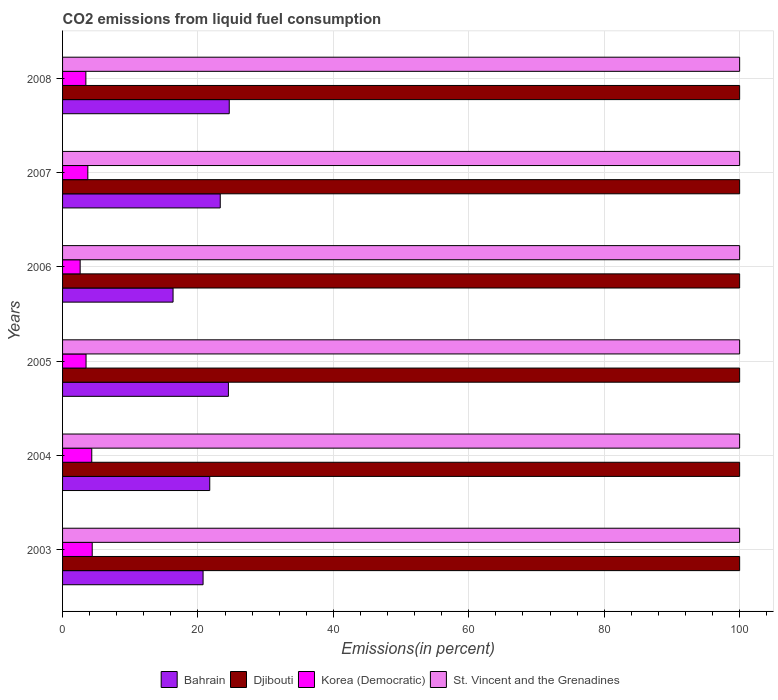How many different coloured bars are there?
Provide a succinct answer. 4. How many groups of bars are there?
Your answer should be very brief. 6. Are the number of bars per tick equal to the number of legend labels?
Provide a short and direct response. Yes. How many bars are there on the 1st tick from the top?
Offer a very short reply. 4. In how many cases, is the number of bars for a given year not equal to the number of legend labels?
Make the answer very short. 0. What is the total CO2 emitted in Korea (Democratic) in 2008?
Offer a very short reply. 3.44. Across all years, what is the maximum total CO2 emitted in Bahrain?
Offer a terse response. 24.62. Across all years, what is the minimum total CO2 emitted in St. Vincent and the Grenadines?
Your answer should be very brief. 100. What is the total total CO2 emitted in Djibouti in the graph?
Ensure brevity in your answer.  600. What is the difference between the total CO2 emitted in Korea (Democratic) in 2007 and the total CO2 emitted in Bahrain in 2003?
Offer a very short reply. -17.02. What is the average total CO2 emitted in Djibouti per year?
Offer a terse response. 100. In the year 2003, what is the difference between the total CO2 emitted in Korea (Democratic) and total CO2 emitted in St. Vincent and the Grenadines?
Keep it short and to the point. -95.62. What is the ratio of the total CO2 emitted in Korea (Democratic) in 2005 to that in 2007?
Your answer should be very brief. 0.93. What is the difference between the highest and the second highest total CO2 emitted in Bahrain?
Ensure brevity in your answer.  0.12. Is it the case that in every year, the sum of the total CO2 emitted in Bahrain and total CO2 emitted in Korea (Democratic) is greater than the sum of total CO2 emitted in St. Vincent and the Grenadines and total CO2 emitted in Djibouti?
Your response must be concise. No. What does the 2nd bar from the top in 2003 represents?
Provide a succinct answer. Korea (Democratic). What does the 1st bar from the bottom in 2007 represents?
Make the answer very short. Bahrain. Are all the bars in the graph horizontal?
Your answer should be very brief. Yes. Does the graph contain grids?
Your answer should be very brief. Yes. How many legend labels are there?
Keep it short and to the point. 4. What is the title of the graph?
Make the answer very short. CO2 emissions from liquid fuel consumption. What is the label or title of the X-axis?
Your answer should be very brief. Emissions(in percent). What is the label or title of the Y-axis?
Your response must be concise. Years. What is the Emissions(in percent) in Bahrain in 2003?
Offer a very short reply. 20.75. What is the Emissions(in percent) of Djibouti in 2003?
Ensure brevity in your answer.  100. What is the Emissions(in percent) in Korea (Democratic) in 2003?
Ensure brevity in your answer.  4.38. What is the Emissions(in percent) of St. Vincent and the Grenadines in 2003?
Your answer should be compact. 100. What is the Emissions(in percent) of Bahrain in 2004?
Your response must be concise. 21.74. What is the Emissions(in percent) in Korea (Democratic) in 2004?
Give a very brief answer. 4.31. What is the Emissions(in percent) of Bahrain in 2005?
Your answer should be compact. 24.49. What is the Emissions(in percent) of Djibouti in 2005?
Offer a very short reply. 100. What is the Emissions(in percent) of Korea (Democratic) in 2005?
Your response must be concise. 3.47. What is the Emissions(in percent) of Bahrain in 2006?
Your answer should be compact. 16.32. What is the Emissions(in percent) in Korea (Democratic) in 2006?
Your answer should be compact. 2.6. What is the Emissions(in percent) of St. Vincent and the Grenadines in 2006?
Give a very brief answer. 100. What is the Emissions(in percent) in Bahrain in 2007?
Offer a very short reply. 23.29. What is the Emissions(in percent) in Korea (Democratic) in 2007?
Your answer should be compact. 3.73. What is the Emissions(in percent) in Bahrain in 2008?
Provide a short and direct response. 24.62. What is the Emissions(in percent) of Korea (Democratic) in 2008?
Make the answer very short. 3.44. Across all years, what is the maximum Emissions(in percent) in Bahrain?
Keep it short and to the point. 24.62. Across all years, what is the maximum Emissions(in percent) in Korea (Democratic)?
Your response must be concise. 4.38. Across all years, what is the minimum Emissions(in percent) of Bahrain?
Your response must be concise. 16.32. Across all years, what is the minimum Emissions(in percent) of Djibouti?
Offer a terse response. 100. Across all years, what is the minimum Emissions(in percent) of Korea (Democratic)?
Make the answer very short. 2.6. Across all years, what is the minimum Emissions(in percent) in St. Vincent and the Grenadines?
Ensure brevity in your answer.  100. What is the total Emissions(in percent) of Bahrain in the graph?
Make the answer very short. 131.21. What is the total Emissions(in percent) in Djibouti in the graph?
Offer a very short reply. 600. What is the total Emissions(in percent) in Korea (Democratic) in the graph?
Ensure brevity in your answer.  21.93. What is the total Emissions(in percent) of St. Vincent and the Grenadines in the graph?
Provide a short and direct response. 600. What is the difference between the Emissions(in percent) in Bahrain in 2003 and that in 2004?
Your answer should be very brief. -0.99. What is the difference between the Emissions(in percent) in Korea (Democratic) in 2003 and that in 2004?
Your answer should be very brief. 0.07. What is the difference between the Emissions(in percent) in St. Vincent and the Grenadines in 2003 and that in 2004?
Provide a short and direct response. 0. What is the difference between the Emissions(in percent) in Bahrain in 2003 and that in 2005?
Make the answer very short. -3.74. What is the difference between the Emissions(in percent) of Djibouti in 2003 and that in 2005?
Provide a succinct answer. 0. What is the difference between the Emissions(in percent) in Korea (Democratic) in 2003 and that in 2005?
Provide a short and direct response. 0.91. What is the difference between the Emissions(in percent) of St. Vincent and the Grenadines in 2003 and that in 2005?
Make the answer very short. 0. What is the difference between the Emissions(in percent) of Bahrain in 2003 and that in 2006?
Keep it short and to the point. 4.43. What is the difference between the Emissions(in percent) of Korea (Democratic) in 2003 and that in 2006?
Provide a short and direct response. 1.78. What is the difference between the Emissions(in percent) of Bahrain in 2003 and that in 2007?
Make the answer very short. -2.54. What is the difference between the Emissions(in percent) of Djibouti in 2003 and that in 2007?
Give a very brief answer. 0. What is the difference between the Emissions(in percent) in Korea (Democratic) in 2003 and that in 2007?
Give a very brief answer. 0.65. What is the difference between the Emissions(in percent) of St. Vincent and the Grenadines in 2003 and that in 2007?
Your answer should be very brief. 0. What is the difference between the Emissions(in percent) in Bahrain in 2003 and that in 2008?
Give a very brief answer. -3.87. What is the difference between the Emissions(in percent) in Djibouti in 2003 and that in 2008?
Keep it short and to the point. 0. What is the difference between the Emissions(in percent) in Korea (Democratic) in 2003 and that in 2008?
Your answer should be very brief. 0.94. What is the difference between the Emissions(in percent) of St. Vincent and the Grenadines in 2003 and that in 2008?
Offer a terse response. 0. What is the difference between the Emissions(in percent) in Bahrain in 2004 and that in 2005?
Keep it short and to the point. -2.76. What is the difference between the Emissions(in percent) in Korea (Democratic) in 2004 and that in 2005?
Provide a short and direct response. 0.85. What is the difference between the Emissions(in percent) in St. Vincent and the Grenadines in 2004 and that in 2005?
Your response must be concise. 0. What is the difference between the Emissions(in percent) in Bahrain in 2004 and that in 2006?
Ensure brevity in your answer.  5.42. What is the difference between the Emissions(in percent) in Korea (Democratic) in 2004 and that in 2006?
Make the answer very short. 1.72. What is the difference between the Emissions(in percent) in Bahrain in 2004 and that in 2007?
Your answer should be very brief. -1.55. What is the difference between the Emissions(in percent) in Korea (Democratic) in 2004 and that in 2007?
Your answer should be very brief. 0.58. What is the difference between the Emissions(in percent) in St. Vincent and the Grenadines in 2004 and that in 2007?
Offer a very short reply. 0. What is the difference between the Emissions(in percent) in Bahrain in 2004 and that in 2008?
Offer a very short reply. -2.88. What is the difference between the Emissions(in percent) of Djibouti in 2004 and that in 2008?
Keep it short and to the point. 0. What is the difference between the Emissions(in percent) in Korea (Democratic) in 2004 and that in 2008?
Keep it short and to the point. 0.87. What is the difference between the Emissions(in percent) of St. Vincent and the Grenadines in 2004 and that in 2008?
Provide a succinct answer. 0. What is the difference between the Emissions(in percent) in Bahrain in 2005 and that in 2006?
Offer a very short reply. 8.17. What is the difference between the Emissions(in percent) in Korea (Democratic) in 2005 and that in 2006?
Your answer should be very brief. 0.87. What is the difference between the Emissions(in percent) in Bahrain in 2005 and that in 2007?
Keep it short and to the point. 1.21. What is the difference between the Emissions(in percent) in Korea (Democratic) in 2005 and that in 2007?
Your answer should be very brief. -0.26. What is the difference between the Emissions(in percent) of Bahrain in 2005 and that in 2008?
Provide a succinct answer. -0.12. What is the difference between the Emissions(in percent) in Korea (Democratic) in 2005 and that in 2008?
Offer a very short reply. 0.03. What is the difference between the Emissions(in percent) in St. Vincent and the Grenadines in 2005 and that in 2008?
Make the answer very short. 0. What is the difference between the Emissions(in percent) in Bahrain in 2006 and that in 2007?
Keep it short and to the point. -6.97. What is the difference between the Emissions(in percent) in Djibouti in 2006 and that in 2007?
Offer a very short reply. 0. What is the difference between the Emissions(in percent) in Korea (Democratic) in 2006 and that in 2007?
Make the answer very short. -1.13. What is the difference between the Emissions(in percent) of St. Vincent and the Grenadines in 2006 and that in 2007?
Keep it short and to the point. 0. What is the difference between the Emissions(in percent) of Bahrain in 2006 and that in 2008?
Offer a terse response. -8.3. What is the difference between the Emissions(in percent) in Djibouti in 2006 and that in 2008?
Keep it short and to the point. 0. What is the difference between the Emissions(in percent) of Korea (Democratic) in 2006 and that in 2008?
Provide a short and direct response. -0.84. What is the difference between the Emissions(in percent) of St. Vincent and the Grenadines in 2006 and that in 2008?
Make the answer very short. 0. What is the difference between the Emissions(in percent) of Bahrain in 2007 and that in 2008?
Give a very brief answer. -1.33. What is the difference between the Emissions(in percent) in Djibouti in 2007 and that in 2008?
Make the answer very short. 0. What is the difference between the Emissions(in percent) of Korea (Democratic) in 2007 and that in 2008?
Your response must be concise. 0.29. What is the difference between the Emissions(in percent) of St. Vincent and the Grenadines in 2007 and that in 2008?
Offer a terse response. 0. What is the difference between the Emissions(in percent) in Bahrain in 2003 and the Emissions(in percent) in Djibouti in 2004?
Your answer should be compact. -79.25. What is the difference between the Emissions(in percent) in Bahrain in 2003 and the Emissions(in percent) in Korea (Democratic) in 2004?
Your answer should be compact. 16.44. What is the difference between the Emissions(in percent) of Bahrain in 2003 and the Emissions(in percent) of St. Vincent and the Grenadines in 2004?
Your answer should be very brief. -79.25. What is the difference between the Emissions(in percent) in Djibouti in 2003 and the Emissions(in percent) in Korea (Democratic) in 2004?
Offer a very short reply. 95.69. What is the difference between the Emissions(in percent) in Djibouti in 2003 and the Emissions(in percent) in St. Vincent and the Grenadines in 2004?
Offer a very short reply. 0. What is the difference between the Emissions(in percent) in Korea (Democratic) in 2003 and the Emissions(in percent) in St. Vincent and the Grenadines in 2004?
Give a very brief answer. -95.62. What is the difference between the Emissions(in percent) of Bahrain in 2003 and the Emissions(in percent) of Djibouti in 2005?
Give a very brief answer. -79.25. What is the difference between the Emissions(in percent) of Bahrain in 2003 and the Emissions(in percent) of Korea (Democratic) in 2005?
Make the answer very short. 17.29. What is the difference between the Emissions(in percent) in Bahrain in 2003 and the Emissions(in percent) in St. Vincent and the Grenadines in 2005?
Your answer should be very brief. -79.25. What is the difference between the Emissions(in percent) in Djibouti in 2003 and the Emissions(in percent) in Korea (Democratic) in 2005?
Offer a terse response. 96.53. What is the difference between the Emissions(in percent) in Djibouti in 2003 and the Emissions(in percent) in St. Vincent and the Grenadines in 2005?
Make the answer very short. 0. What is the difference between the Emissions(in percent) in Korea (Democratic) in 2003 and the Emissions(in percent) in St. Vincent and the Grenadines in 2005?
Offer a very short reply. -95.62. What is the difference between the Emissions(in percent) in Bahrain in 2003 and the Emissions(in percent) in Djibouti in 2006?
Make the answer very short. -79.25. What is the difference between the Emissions(in percent) of Bahrain in 2003 and the Emissions(in percent) of Korea (Democratic) in 2006?
Offer a terse response. 18.15. What is the difference between the Emissions(in percent) of Bahrain in 2003 and the Emissions(in percent) of St. Vincent and the Grenadines in 2006?
Make the answer very short. -79.25. What is the difference between the Emissions(in percent) of Djibouti in 2003 and the Emissions(in percent) of Korea (Democratic) in 2006?
Give a very brief answer. 97.4. What is the difference between the Emissions(in percent) of Djibouti in 2003 and the Emissions(in percent) of St. Vincent and the Grenadines in 2006?
Your answer should be very brief. 0. What is the difference between the Emissions(in percent) in Korea (Democratic) in 2003 and the Emissions(in percent) in St. Vincent and the Grenadines in 2006?
Your answer should be compact. -95.62. What is the difference between the Emissions(in percent) in Bahrain in 2003 and the Emissions(in percent) in Djibouti in 2007?
Give a very brief answer. -79.25. What is the difference between the Emissions(in percent) of Bahrain in 2003 and the Emissions(in percent) of Korea (Democratic) in 2007?
Your response must be concise. 17.02. What is the difference between the Emissions(in percent) of Bahrain in 2003 and the Emissions(in percent) of St. Vincent and the Grenadines in 2007?
Your answer should be compact. -79.25. What is the difference between the Emissions(in percent) in Djibouti in 2003 and the Emissions(in percent) in Korea (Democratic) in 2007?
Your answer should be compact. 96.27. What is the difference between the Emissions(in percent) of Korea (Democratic) in 2003 and the Emissions(in percent) of St. Vincent and the Grenadines in 2007?
Offer a very short reply. -95.62. What is the difference between the Emissions(in percent) in Bahrain in 2003 and the Emissions(in percent) in Djibouti in 2008?
Provide a succinct answer. -79.25. What is the difference between the Emissions(in percent) of Bahrain in 2003 and the Emissions(in percent) of Korea (Democratic) in 2008?
Make the answer very short. 17.31. What is the difference between the Emissions(in percent) of Bahrain in 2003 and the Emissions(in percent) of St. Vincent and the Grenadines in 2008?
Offer a very short reply. -79.25. What is the difference between the Emissions(in percent) of Djibouti in 2003 and the Emissions(in percent) of Korea (Democratic) in 2008?
Provide a succinct answer. 96.56. What is the difference between the Emissions(in percent) in Korea (Democratic) in 2003 and the Emissions(in percent) in St. Vincent and the Grenadines in 2008?
Ensure brevity in your answer.  -95.62. What is the difference between the Emissions(in percent) of Bahrain in 2004 and the Emissions(in percent) of Djibouti in 2005?
Provide a succinct answer. -78.26. What is the difference between the Emissions(in percent) in Bahrain in 2004 and the Emissions(in percent) in Korea (Democratic) in 2005?
Provide a succinct answer. 18.27. What is the difference between the Emissions(in percent) of Bahrain in 2004 and the Emissions(in percent) of St. Vincent and the Grenadines in 2005?
Provide a short and direct response. -78.26. What is the difference between the Emissions(in percent) of Djibouti in 2004 and the Emissions(in percent) of Korea (Democratic) in 2005?
Ensure brevity in your answer.  96.53. What is the difference between the Emissions(in percent) of Korea (Democratic) in 2004 and the Emissions(in percent) of St. Vincent and the Grenadines in 2005?
Offer a terse response. -95.69. What is the difference between the Emissions(in percent) in Bahrain in 2004 and the Emissions(in percent) in Djibouti in 2006?
Provide a succinct answer. -78.26. What is the difference between the Emissions(in percent) in Bahrain in 2004 and the Emissions(in percent) in Korea (Democratic) in 2006?
Provide a succinct answer. 19.14. What is the difference between the Emissions(in percent) in Bahrain in 2004 and the Emissions(in percent) in St. Vincent and the Grenadines in 2006?
Your response must be concise. -78.26. What is the difference between the Emissions(in percent) in Djibouti in 2004 and the Emissions(in percent) in Korea (Democratic) in 2006?
Make the answer very short. 97.4. What is the difference between the Emissions(in percent) in Djibouti in 2004 and the Emissions(in percent) in St. Vincent and the Grenadines in 2006?
Ensure brevity in your answer.  0. What is the difference between the Emissions(in percent) of Korea (Democratic) in 2004 and the Emissions(in percent) of St. Vincent and the Grenadines in 2006?
Your response must be concise. -95.69. What is the difference between the Emissions(in percent) of Bahrain in 2004 and the Emissions(in percent) of Djibouti in 2007?
Make the answer very short. -78.26. What is the difference between the Emissions(in percent) in Bahrain in 2004 and the Emissions(in percent) in Korea (Democratic) in 2007?
Your response must be concise. 18.01. What is the difference between the Emissions(in percent) of Bahrain in 2004 and the Emissions(in percent) of St. Vincent and the Grenadines in 2007?
Keep it short and to the point. -78.26. What is the difference between the Emissions(in percent) of Djibouti in 2004 and the Emissions(in percent) of Korea (Democratic) in 2007?
Make the answer very short. 96.27. What is the difference between the Emissions(in percent) of Djibouti in 2004 and the Emissions(in percent) of St. Vincent and the Grenadines in 2007?
Give a very brief answer. 0. What is the difference between the Emissions(in percent) in Korea (Democratic) in 2004 and the Emissions(in percent) in St. Vincent and the Grenadines in 2007?
Your answer should be very brief. -95.69. What is the difference between the Emissions(in percent) of Bahrain in 2004 and the Emissions(in percent) of Djibouti in 2008?
Your answer should be compact. -78.26. What is the difference between the Emissions(in percent) in Bahrain in 2004 and the Emissions(in percent) in Korea (Democratic) in 2008?
Your answer should be compact. 18.3. What is the difference between the Emissions(in percent) in Bahrain in 2004 and the Emissions(in percent) in St. Vincent and the Grenadines in 2008?
Your response must be concise. -78.26. What is the difference between the Emissions(in percent) of Djibouti in 2004 and the Emissions(in percent) of Korea (Democratic) in 2008?
Your answer should be compact. 96.56. What is the difference between the Emissions(in percent) in Djibouti in 2004 and the Emissions(in percent) in St. Vincent and the Grenadines in 2008?
Offer a very short reply. 0. What is the difference between the Emissions(in percent) in Korea (Democratic) in 2004 and the Emissions(in percent) in St. Vincent and the Grenadines in 2008?
Your answer should be compact. -95.69. What is the difference between the Emissions(in percent) of Bahrain in 2005 and the Emissions(in percent) of Djibouti in 2006?
Provide a succinct answer. -75.51. What is the difference between the Emissions(in percent) of Bahrain in 2005 and the Emissions(in percent) of Korea (Democratic) in 2006?
Make the answer very short. 21.9. What is the difference between the Emissions(in percent) in Bahrain in 2005 and the Emissions(in percent) in St. Vincent and the Grenadines in 2006?
Give a very brief answer. -75.51. What is the difference between the Emissions(in percent) of Djibouti in 2005 and the Emissions(in percent) of Korea (Democratic) in 2006?
Give a very brief answer. 97.4. What is the difference between the Emissions(in percent) in Djibouti in 2005 and the Emissions(in percent) in St. Vincent and the Grenadines in 2006?
Make the answer very short. 0. What is the difference between the Emissions(in percent) in Korea (Democratic) in 2005 and the Emissions(in percent) in St. Vincent and the Grenadines in 2006?
Give a very brief answer. -96.53. What is the difference between the Emissions(in percent) of Bahrain in 2005 and the Emissions(in percent) of Djibouti in 2007?
Ensure brevity in your answer.  -75.51. What is the difference between the Emissions(in percent) in Bahrain in 2005 and the Emissions(in percent) in Korea (Democratic) in 2007?
Your answer should be very brief. 20.76. What is the difference between the Emissions(in percent) of Bahrain in 2005 and the Emissions(in percent) of St. Vincent and the Grenadines in 2007?
Provide a short and direct response. -75.51. What is the difference between the Emissions(in percent) in Djibouti in 2005 and the Emissions(in percent) in Korea (Democratic) in 2007?
Your answer should be compact. 96.27. What is the difference between the Emissions(in percent) in Korea (Democratic) in 2005 and the Emissions(in percent) in St. Vincent and the Grenadines in 2007?
Ensure brevity in your answer.  -96.53. What is the difference between the Emissions(in percent) of Bahrain in 2005 and the Emissions(in percent) of Djibouti in 2008?
Provide a succinct answer. -75.51. What is the difference between the Emissions(in percent) of Bahrain in 2005 and the Emissions(in percent) of Korea (Democratic) in 2008?
Offer a very short reply. 21.05. What is the difference between the Emissions(in percent) of Bahrain in 2005 and the Emissions(in percent) of St. Vincent and the Grenadines in 2008?
Provide a short and direct response. -75.51. What is the difference between the Emissions(in percent) in Djibouti in 2005 and the Emissions(in percent) in Korea (Democratic) in 2008?
Offer a terse response. 96.56. What is the difference between the Emissions(in percent) of Djibouti in 2005 and the Emissions(in percent) of St. Vincent and the Grenadines in 2008?
Offer a terse response. 0. What is the difference between the Emissions(in percent) in Korea (Democratic) in 2005 and the Emissions(in percent) in St. Vincent and the Grenadines in 2008?
Make the answer very short. -96.53. What is the difference between the Emissions(in percent) in Bahrain in 2006 and the Emissions(in percent) in Djibouti in 2007?
Keep it short and to the point. -83.68. What is the difference between the Emissions(in percent) in Bahrain in 2006 and the Emissions(in percent) in Korea (Democratic) in 2007?
Provide a succinct answer. 12.59. What is the difference between the Emissions(in percent) of Bahrain in 2006 and the Emissions(in percent) of St. Vincent and the Grenadines in 2007?
Make the answer very short. -83.68. What is the difference between the Emissions(in percent) of Djibouti in 2006 and the Emissions(in percent) of Korea (Democratic) in 2007?
Your answer should be very brief. 96.27. What is the difference between the Emissions(in percent) of Korea (Democratic) in 2006 and the Emissions(in percent) of St. Vincent and the Grenadines in 2007?
Offer a terse response. -97.4. What is the difference between the Emissions(in percent) in Bahrain in 2006 and the Emissions(in percent) in Djibouti in 2008?
Ensure brevity in your answer.  -83.68. What is the difference between the Emissions(in percent) of Bahrain in 2006 and the Emissions(in percent) of Korea (Democratic) in 2008?
Give a very brief answer. 12.88. What is the difference between the Emissions(in percent) in Bahrain in 2006 and the Emissions(in percent) in St. Vincent and the Grenadines in 2008?
Offer a terse response. -83.68. What is the difference between the Emissions(in percent) of Djibouti in 2006 and the Emissions(in percent) of Korea (Democratic) in 2008?
Offer a very short reply. 96.56. What is the difference between the Emissions(in percent) in Korea (Democratic) in 2006 and the Emissions(in percent) in St. Vincent and the Grenadines in 2008?
Ensure brevity in your answer.  -97.4. What is the difference between the Emissions(in percent) of Bahrain in 2007 and the Emissions(in percent) of Djibouti in 2008?
Your answer should be compact. -76.71. What is the difference between the Emissions(in percent) in Bahrain in 2007 and the Emissions(in percent) in Korea (Democratic) in 2008?
Offer a terse response. 19.85. What is the difference between the Emissions(in percent) in Bahrain in 2007 and the Emissions(in percent) in St. Vincent and the Grenadines in 2008?
Provide a succinct answer. -76.71. What is the difference between the Emissions(in percent) in Djibouti in 2007 and the Emissions(in percent) in Korea (Democratic) in 2008?
Give a very brief answer. 96.56. What is the difference between the Emissions(in percent) of Djibouti in 2007 and the Emissions(in percent) of St. Vincent and the Grenadines in 2008?
Offer a very short reply. 0. What is the difference between the Emissions(in percent) of Korea (Democratic) in 2007 and the Emissions(in percent) of St. Vincent and the Grenadines in 2008?
Your answer should be very brief. -96.27. What is the average Emissions(in percent) in Bahrain per year?
Your response must be concise. 21.87. What is the average Emissions(in percent) of Djibouti per year?
Offer a very short reply. 100. What is the average Emissions(in percent) in Korea (Democratic) per year?
Your answer should be very brief. 3.66. What is the average Emissions(in percent) in St. Vincent and the Grenadines per year?
Make the answer very short. 100. In the year 2003, what is the difference between the Emissions(in percent) in Bahrain and Emissions(in percent) in Djibouti?
Your answer should be compact. -79.25. In the year 2003, what is the difference between the Emissions(in percent) in Bahrain and Emissions(in percent) in Korea (Democratic)?
Offer a very short reply. 16.37. In the year 2003, what is the difference between the Emissions(in percent) in Bahrain and Emissions(in percent) in St. Vincent and the Grenadines?
Offer a very short reply. -79.25. In the year 2003, what is the difference between the Emissions(in percent) of Djibouti and Emissions(in percent) of Korea (Democratic)?
Give a very brief answer. 95.62. In the year 2003, what is the difference between the Emissions(in percent) of Djibouti and Emissions(in percent) of St. Vincent and the Grenadines?
Offer a very short reply. 0. In the year 2003, what is the difference between the Emissions(in percent) of Korea (Democratic) and Emissions(in percent) of St. Vincent and the Grenadines?
Your response must be concise. -95.62. In the year 2004, what is the difference between the Emissions(in percent) in Bahrain and Emissions(in percent) in Djibouti?
Your answer should be compact. -78.26. In the year 2004, what is the difference between the Emissions(in percent) of Bahrain and Emissions(in percent) of Korea (Democratic)?
Your answer should be very brief. 17.42. In the year 2004, what is the difference between the Emissions(in percent) in Bahrain and Emissions(in percent) in St. Vincent and the Grenadines?
Your answer should be compact. -78.26. In the year 2004, what is the difference between the Emissions(in percent) in Djibouti and Emissions(in percent) in Korea (Democratic)?
Your response must be concise. 95.69. In the year 2004, what is the difference between the Emissions(in percent) in Djibouti and Emissions(in percent) in St. Vincent and the Grenadines?
Give a very brief answer. 0. In the year 2004, what is the difference between the Emissions(in percent) in Korea (Democratic) and Emissions(in percent) in St. Vincent and the Grenadines?
Keep it short and to the point. -95.69. In the year 2005, what is the difference between the Emissions(in percent) of Bahrain and Emissions(in percent) of Djibouti?
Offer a very short reply. -75.51. In the year 2005, what is the difference between the Emissions(in percent) in Bahrain and Emissions(in percent) in Korea (Democratic)?
Offer a terse response. 21.03. In the year 2005, what is the difference between the Emissions(in percent) in Bahrain and Emissions(in percent) in St. Vincent and the Grenadines?
Give a very brief answer. -75.51. In the year 2005, what is the difference between the Emissions(in percent) of Djibouti and Emissions(in percent) of Korea (Democratic)?
Your answer should be very brief. 96.53. In the year 2005, what is the difference between the Emissions(in percent) of Djibouti and Emissions(in percent) of St. Vincent and the Grenadines?
Offer a very short reply. 0. In the year 2005, what is the difference between the Emissions(in percent) of Korea (Democratic) and Emissions(in percent) of St. Vincent and the Grenadines?
Offer a terse response. -96.53. In the year 2006, what is the difference between the Emissions(in percent) of Bahrain and Emissions(in percent) of Djibouti?
Give a very brief answer. -83.68. In the year 2006, what is the difference between the Emissions(in percent) in Bahrain and Emissions(in percent) in Korea (Democratic)?
Provide a short and direct response. 13.72. In the year 2006, what is the difference between the Emissions(in percent) of Bahrain and Emissions(in percent) of St. Vincent and the Grenadines?
Provide a succinct answer. -83.68. In the year 2006, what is the difference between the Emissions(in percent) of Djibouti and Emissions(in percent) of Korea (Democratic)?
Keep it short and to the point. 97.4. In the year 2006, what is the difference between the Emissions(in percent) in Djibouti and Emissions(in percent) in St. Vincent and the Grenadines?
Offer a very short reply. 0. In the year 2006, what is the difference between the Emissions(in percent) of Korea (Democratic) and Emissions(in percent) of St. Vincent and the Grenadines?
Give a very brief answer. -97.4. In the year 2007, what is the difference between the Emissions(in percent) in Bahrain and Emissions(in percent) in Djibouti?
Your answer should be very brief. -76.71. In the year 2007, what is the difference between the Emissions(in percent) in Bahrain and Emissions(in percent) in Korea (Democratic)?
Ensure brevity in your answer.  19.56. In the year 2007, what is the difference between the Emissions(in percent) in Bahrain and Emissions(in percent) in St. Vincent and the Grenadines?
Make the answer very short. -76.71. In the year 2007, what is the difference between the Emissions(in percent) of Djibouti and Emissions(in percent) of Korea (Democratic)?
Offer a very short reply. 96.27. In the year 2007, what is the difference between the Emissions(in percent) of Korea (Democratic) and Emissions(in percent) of St. Vincent and the Grenadines?
Offer a very short reply. -96.27. In the year 2008, what is the difference between the Emissions(in percent) in Bahrain and Emissions(in percent) in Djibouti?
Keep it short and to the point. -75.38. In the year 2008, what is the difference between the Emissions(in percent) of Bahrain and Emissions(in percent) of Korea (Democratic)?
Provide a short and direct response. 21.18. In the year 2008, what is the difference between the Emissions(in percent) in Bahrain and Emissions(in percent) in St. Vincent and the Grenadines?
Offer a very short reply. -75.38. In the year 2008, what is the difference between the Emissions(in percent) in Djibouti and Emissions(in percent) in Korea (Democratic)?
Your answer should be compact. 96.56. In the year 2008, what is the difference between the Emissions(in percent) in Djibouti and Emissions(in percent) in St. Vincent and the Grenadines?
Ensure brevity in your answer.  0. In the year 2008, what is the difference between the Emissions(in percent) of Korea (Democratic) and Emissions(in percent) of St. Vincent and the Grenadines?
Ensure brevity in your answer.  -96.56. What is the ratio of the Emissions(in percent) in Bahrain in 2003 to that in 2004?
Your answer should be very brief. 0.95. What is the ratio of the Emissions(in percent) in Korea (Democratic) in 2003 to that in 2004?
Your response must be concise. 1.02. What is the ratio of the Emissions(in percent) in Bahrain in 2003 to that in 2005?
Provide a succinct answer. 0.85. What is the ratio of the Emissions(in percent) of Djibouti in 2003 to that in 2005?
Keep it short and to the point. 1. What is the ratio of the Emissions(in percent) of Korea (Democratic) in 2003 to that in 2005?
Make the answer very short. 1.26. What is the ratio of the Emissions(in percent) of Bahrain in 2003 to that in 2006?
Your answer should be compact. 1.27. What is the ratio of the Emissions(in percent) of Korea (Democratic) in 2003 to that in 2006?
Provide a short and direct response. 1.69. What is the ratio of the Emissions(in percent) of St. Vincent and the Grenadines in 2003 to that in 2006?
Ensure brevity in your answer.  1. What is the ratio of the Emissions(in percent) in Bahrain in 2003 to that in 2007?
Give a very brief answer. 0.89. What is the ratio of the Emissions(in percent) of Djibouti in 2003 to that in 2007?
Your response must be concise. 1. What is the ratio of the Emissions(in percent) of Korea (Democratic) in 2003 to that in 2007?
Give a very brief answer. 1.17. What is the ratio of the Emissions(in percent) in Bahrain in 2003 to that in 2008?
Offer a terse response. 0.84. What is the ratio of the Emissions(in percent) of Djibouti in 2003 to that in 2008?
Keep it short and to the point. 1. What is the ratio of the Emissions(in percent) of Korea (Democratic) in 2003 to that in 2008?
Give a very brief answer. 1.27. What is the ratio of the Emissions(in percent) of Bahrain in 2004 to that in 2005?
Offer a terse response. 0.89. What is the ratio of the Emissions(in percent) of Djibouti in 2004 to that in 2005?
Ensure brevity in your answer.  1. What is the ratio of the Emissions(in percent) in Korea (Democratic) in 2004 to that in 2005?
Your answer should be compact. 1.24. What is the ratio of the Emissions(in percent) of Bahrain in 2004 to that in 2006?
Offer a terse response. 1.33. What is the ratio of the Emissions(in percent) in Korea (Democratic) in 2004 to that in 2006?
Give a very brief answer. 1.66. What is the ratio of the Emissions(in percent) in St. Vincent and the Grenadines in 2004 to that in 2006?
Offer a terse response. 1. What is the ratio of the Emissions(in percent) of Bahrain in 2004 to that in 2007?
Provide a short and direct response. 0.93. What is the ratio of the Emissions(in percent) in Djibouti in 2004 to that in 2007?
Provide a succinct answer. 1. What is the ratio of the Emissions(in percent) of Korea (Democratic) in 2004 to that in 2007?
Provide a short and direct response. 1.16. What is the ratio of the Emissions(in percent) of St. Vincent and the Grenadines in 2004 to that in 2007?
Your answer should be very brief. 1. What is the ratio of the Emissions(in percent) in Bahrain in 2004 to that in 2008?
Provide a short and direct response. 0.88. What is the ratio of the Emissions(in percent) of Korea (Democratic) in 2004 to that in 2008?
Your response must be concise. 1.25. What is the ratio of the Emissions(in percent) of Bahrain in 2005 to that in 2006?
Your response must be concise. 1.5. What is the ratio of the Emissions(in percent) in Korea (Democratic) in 2005 to that in 2006?
Your answer should be very brief. 1.33. What is the ratio of the Emissions(in percent) in Bahrain in 2005 to that in 2007?
Your answer should be compact. 1.05. What is the ratio of the Emissions(in percent) in Korea (Democratic) in 2005 to that in 2007?
Give a very brief answer. 0.93. What is the ratio of the Emissions(in percent) of St. Vincent and the Grenadines in 2005 to that in 2007?
Ensure brevity in your answer.  1. What is the ratio of the Emissions(in percent) of Korea (Democratic) in 2005 to that in 2008?
Ensure brevity in your answer.  1.01. What is the ratio of the Emissions(in percent) in St. Vincent and the Grenadines in 2005 to that in 2008?
Ensure brevity in your answer.  1. What is the ratio of the Emissions(in percent) in Bahrain in 2006 to that in 2007?
Your response must be concise. 0.7. What is the ratio of the Emissions(in percent) in Djibouti in 2006 to that in 2007?
Ensure brevity in your answer.  1. What is the ratio of the Emissions(in percent) of Korea (Democratic) in 2006 to that in 2007?
Provide a short and direct response. 0.7. What is the ratio of the Emissions(in percent) of St. Vincent and the Grenadines in 2006 to that in 2007?
Offer a very short reply. 1. What is the ratio of the Emissions(in percent) of Bahrain in 2006 to that in 2008?
Make the answer very short. 0.66. What is the ratio of the Emissions(in percent) in Korea (Democratic) in 2006 to that in 2008?
Provide a short and direct response. 0.75. What is the ratio of the Emissions(in percent) in St. Vincent and the Grenadines in 2006 to that in 2008?
Your answer should be very brief. 1. What is the ratio of the Emissions(in percent) in Bahrain in 2007 to that in 2008?
Offer a terse response. 0.95. What is the ratio of the Emissions(in percent) in Djibouti in 2007 to that in 2008?
Give a very brief answer. 1. What is the ratio of the Emissions(in percent) of Korea (Democratic) in 2007 to that in 2008?
Your response must be concise. 1.08. What is the difference between the highest and the second highest Emissions(in percent) in Bahrain?
Give a very brief answer. 0.12. What is the difference between the highest and the second highest Emissions(in percent) in Korea (Democratic)?
Provide a short and direct response. 0.07. What is the difference between the highest and the second highest Emissions(in percent) in St. Vincent and the Grenadines?
Your answer should be very brief. 0. What is the difference between the highest and the lowest Emissions(in percent) in Bahrain?
Provide a succinct answer. 8.3. What is the difference between the highest and the lowest Emissions(in percent) in Djibouti?
Ensure brevity in your answer.  0. What is the difference between the highest and the lowest Emissions(in percent) in Korea (Democratic)?
Make the answer very short. 1.78. What is the difference between the highest and the lowest Emissions(in percent) in St. Vincent and the Grenadines?
Offer a terse response. 0. 